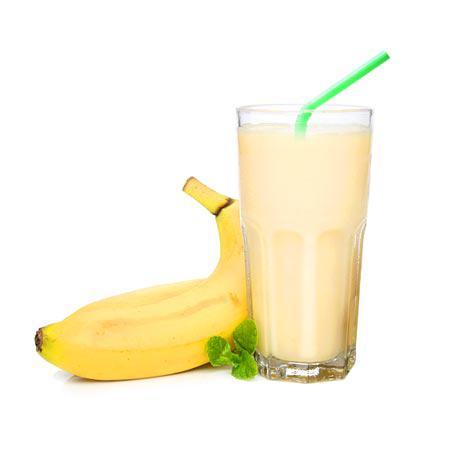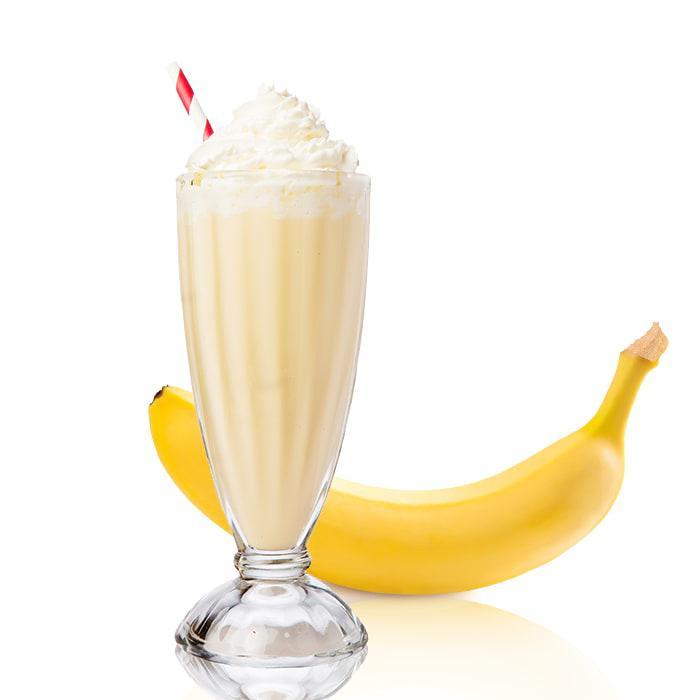The first image is the image on the left, the second image is the image on the right. Evaluate the accuracy of this statement regarding the images: "All the bananas are cut.". Is it true? Answer yes or no. No. 